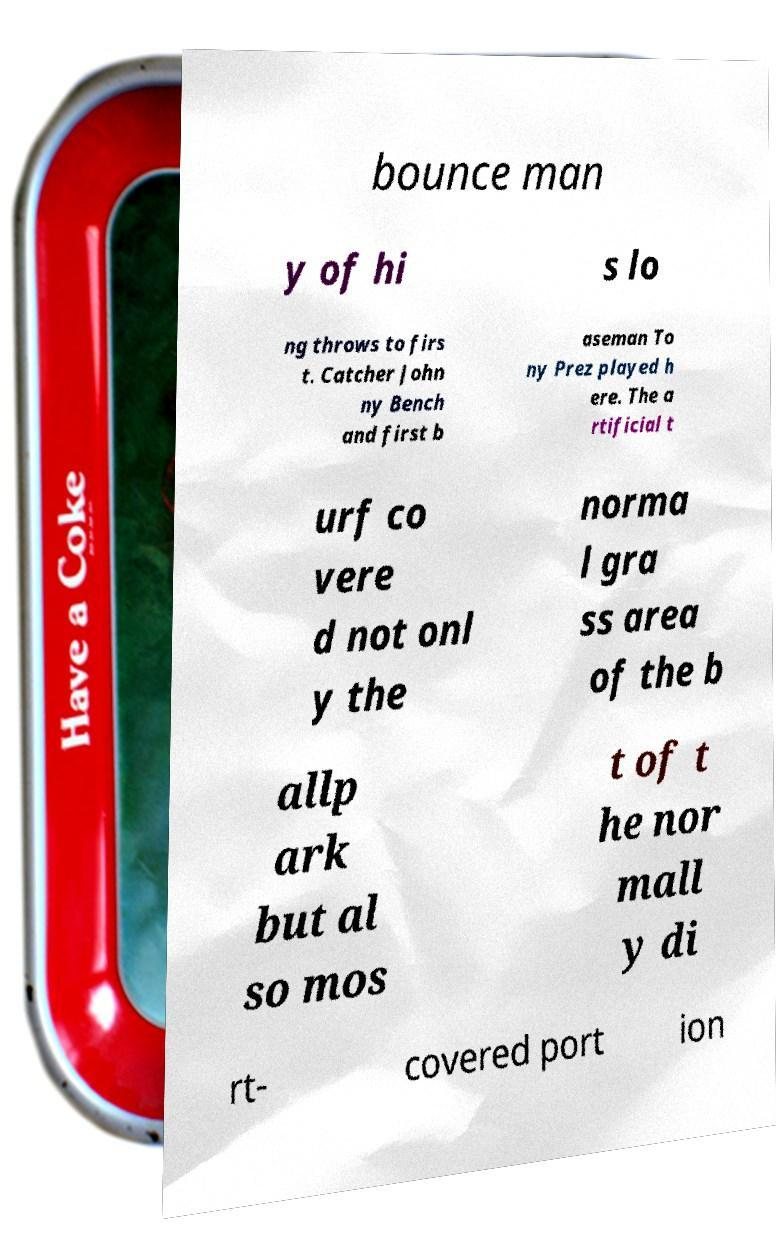I need the written content from this picture converted into text. Can you do that? bounce man y of hi s lo ng throws to firs t. Catcher John ny Bench and first b aseman To ny Prez played h ere. The a rtificial t urf co vere d not onl y the norma l gra ss area of the b allp ark but al so mos t of t he nor mall y di rt- covered port ion 